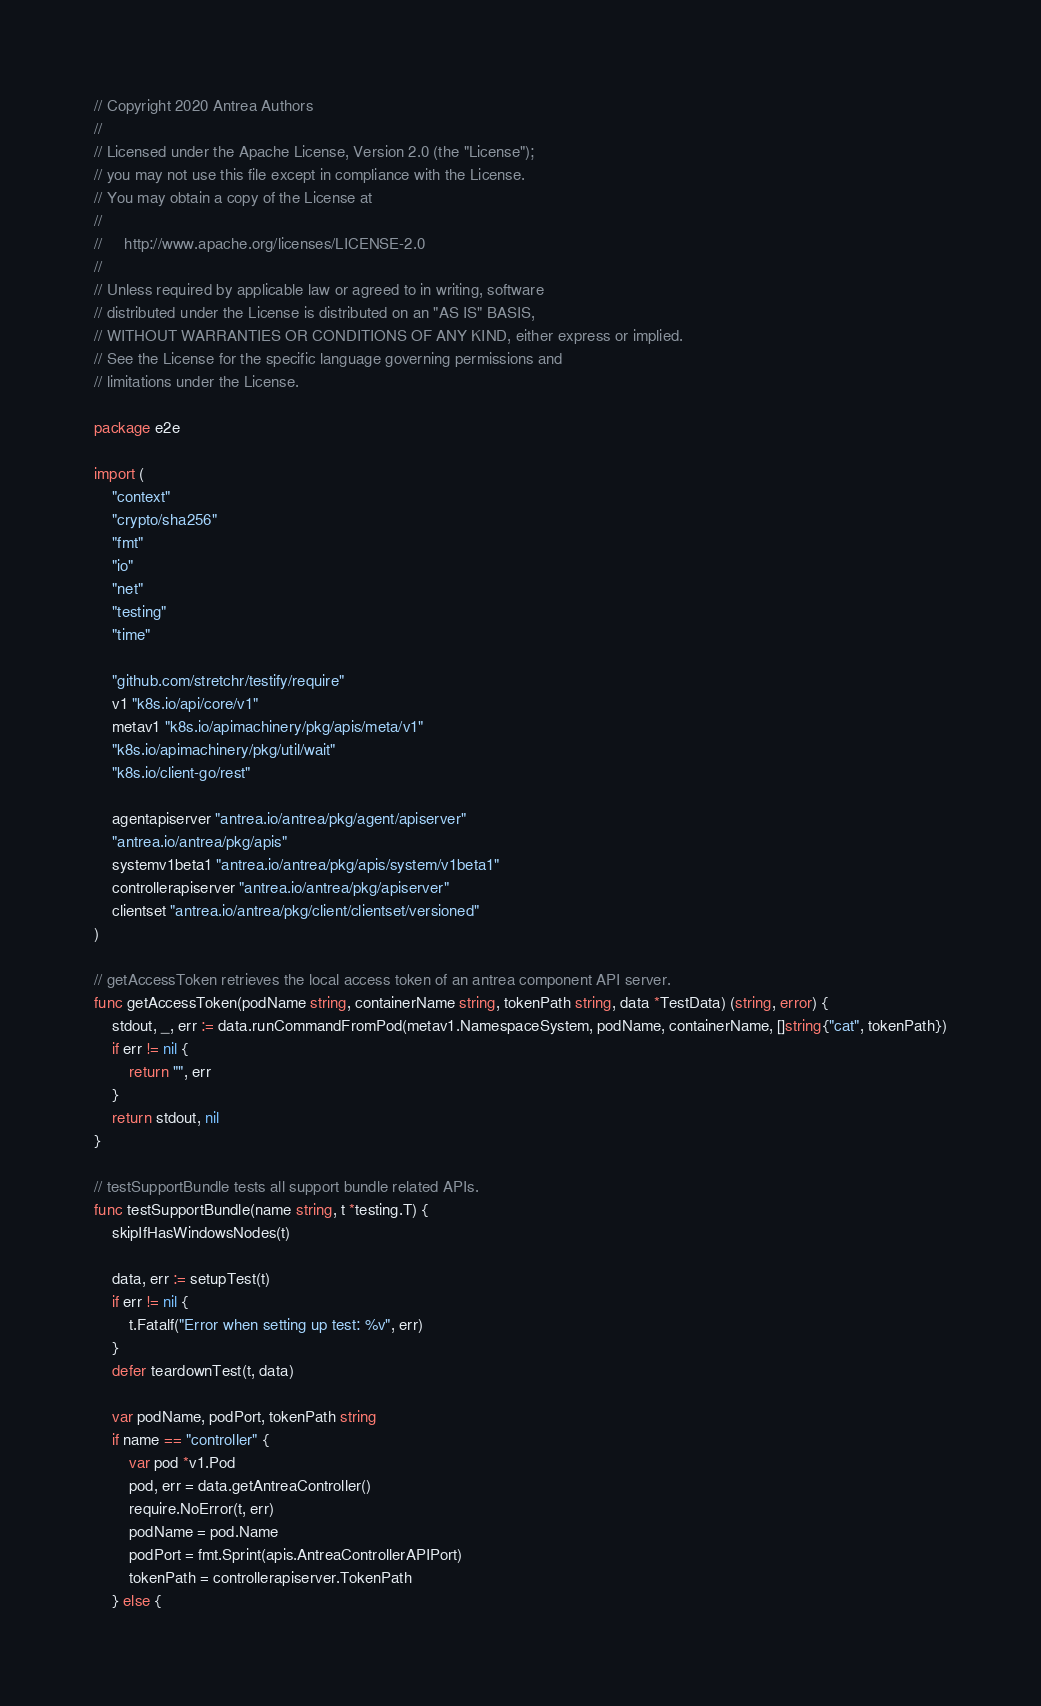<code> <loc_0><loc_0><loc_500><loc_500><_Go_>// Copyright 2020 Antrea Authors
//
// Licensed under the Apache License, Version 2.0 (the "License");
// you may not use this file except in compliance with the License.
// You may obtain a copy of the License at
//
//     http://www.apache.org/licenses/LICENSE-2.0
//
// Unless required by applicable law or agreed to in writing, software
// distributed under the License is distributed on an "AS IS" BASIS,
// WITHOUT WARRANTIES OR CONDITIONS OF ANY KIND, either express or implied.
// See the License for the specific language governing permissions and
// limitations under the License.

package e2e

import (
	"context"
	"crypto/sha256"
	"fmt"
	"io"
	"net"
	"testing"
	"time"

	"github.com/stretchr/testify/require"
	v1 "k8s.io/api/core/v1"
	metav1 "k8s.io/apimachinery/pkg/apis/meta/v1"
	"k8s.io/apimachinery/pkg/util/wait"
	"k8s.io/client-go/rest"

	agentapiserver "antrea.io/antrea/pkg/agent/apiserver"
	"antrea.io/antrea/pkg/apis"
	systemv1beta1 "antrea.io/antrea/pkg/apis/system/v1beta1"
	controllerapiserver "antrea.io/antrea/pkg/apiserver"
	clientset "antrea.io/antrea/pkg/client/clientset/versioned"
)

// getAccessToken retrieves the local access token of an antrea component API server.
func getAccessToken(podName string, containerName string, tokenPath string, data *TestData) (string, error) {
	stdout, _, err := data.runCommandFromPod(metav1.NamespaceSystem, podName, containerName, []string{"cat", tokenPath})
	if err != nil {
		return "", err
	}
	return stdout, nil
}

// testSupportBundle tests all support bundle related APIs.
func testSupportBundle(name string, t *testing.T) {
	skipIfHasWindowsNodes(t)

	data, err := setupTest(t)
	if err != nil {
		t.Fatalf("Error when setting up test: %v", err)
	}
	defer teardownTest(t, data)

	var podName, podPort, tokenPath string
	if name == "controller" {
		var pod *v1.Pod
		pod, err = data.getAntreaController()
		require.NoError(t, err)
		podName = pod.Name
		podPort = fmt.Sprint(apis.AntreaControllerAPIPort)
		tokenPath = controllerapiserver.TokenPath
	} else {</code> 